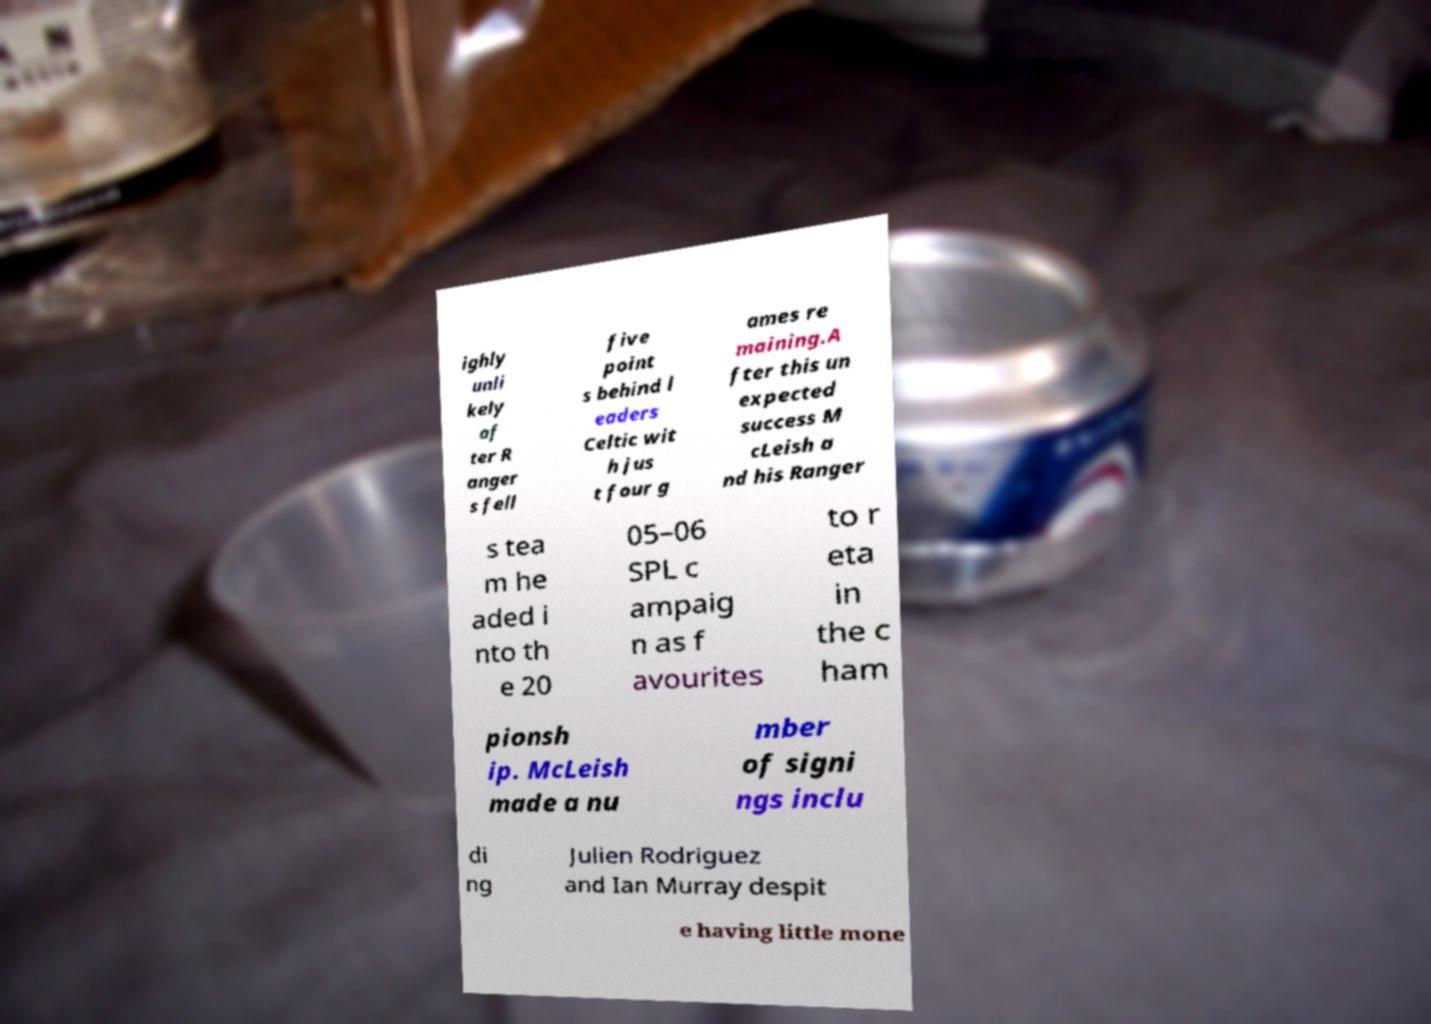Could you extract and type out the text from this image? ighly unli kely af ter R anger s fell five point s behind l eaders Celtic wit h jus t four g ames re maining.A fter this un expected success M cLeish a nd his Ranger s tea m he aded i nto th e 20 05–06 SPL c ampaig n as f avourites to r eta in the c ham pionsh ip. McLeish made a nu mber of signi ngs inclu di ng Julien Rodriguez and Ian Murray despit e having little mone 